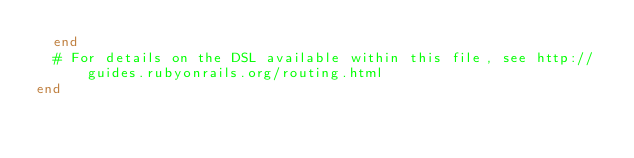Convert code to text. <code><loc_0><loc_0><loc_500><loc_500><_Ruby_>	end
  # For details on the DSL available within this file, see http://guides.rubyonrails.org/routing.html
end</code> 